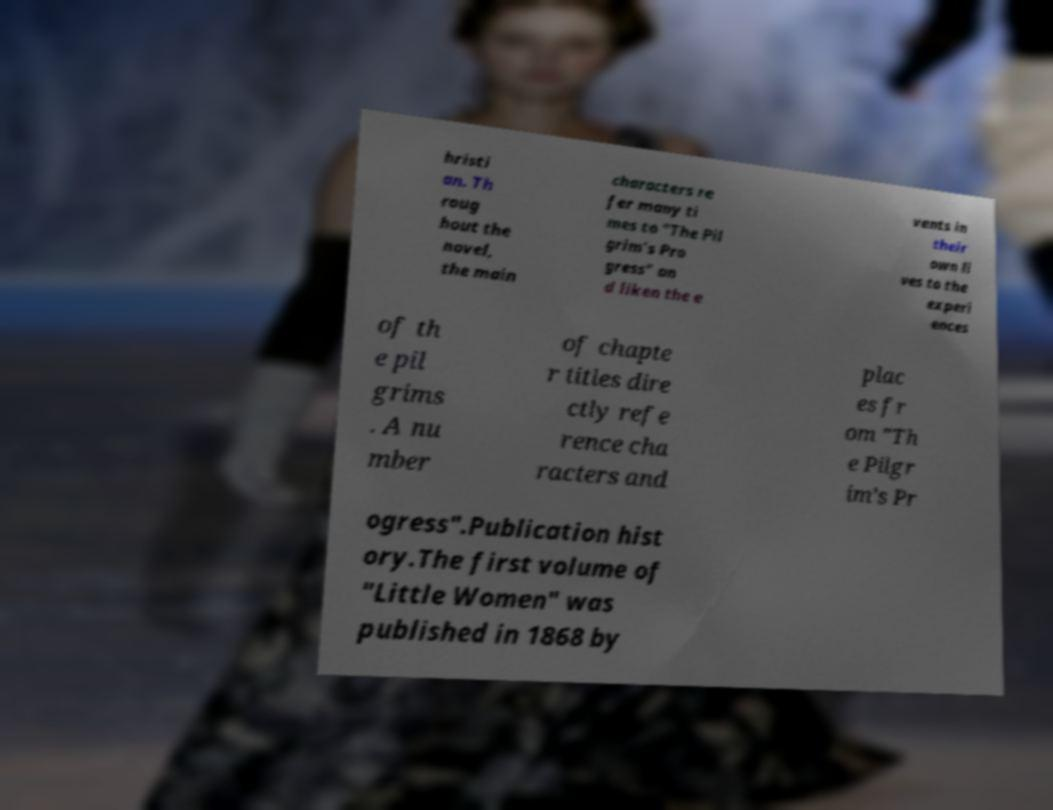Can you read and provide the text displayed in the image?This photo seems to have some interesting text. Can you extract and type it out for me? hristi an. Th roug hout the novel, the main characters re fer many ti mes to "The Pil grim’s Pro gress" an d liken the e vents in their own li ves to the experi ences of th e pil grims . A nu mber of chapte r titles dire ctly refe rence cha racters and plac es fr om "Th e Pilgr im’s Pr ogress".Publication hist ory.The first volume of "Little Women" was published in 1868 by 